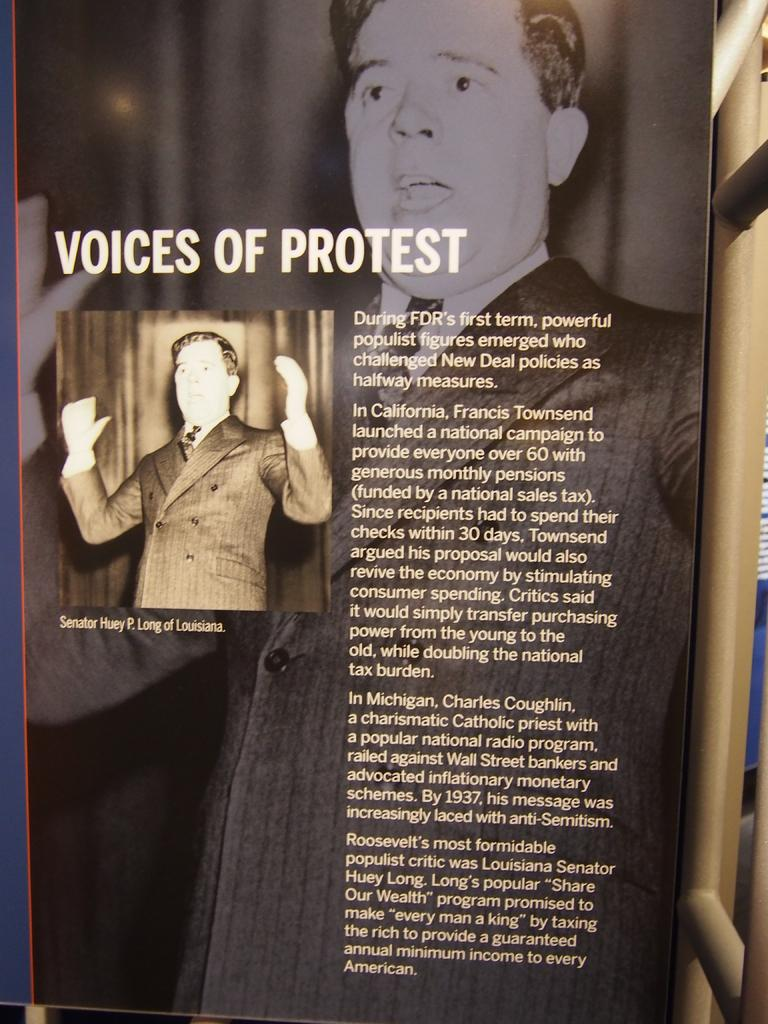What is the main object in the image? There is a banner in the image. What is supporting the banner? There are metal rods beside the banner. What can be seen on the banner? The banner contains images of a person and text. What is the person in the image wearing? The person in the image is wearing a blazer and a tie. What type of stone is used to create the texture of the bucket in the image? There is no bucket or stone present in the image. What is the texture of the person's tie in the image? The provided facts do not mention the texture of the tie, so we cannot determine it from the image. 